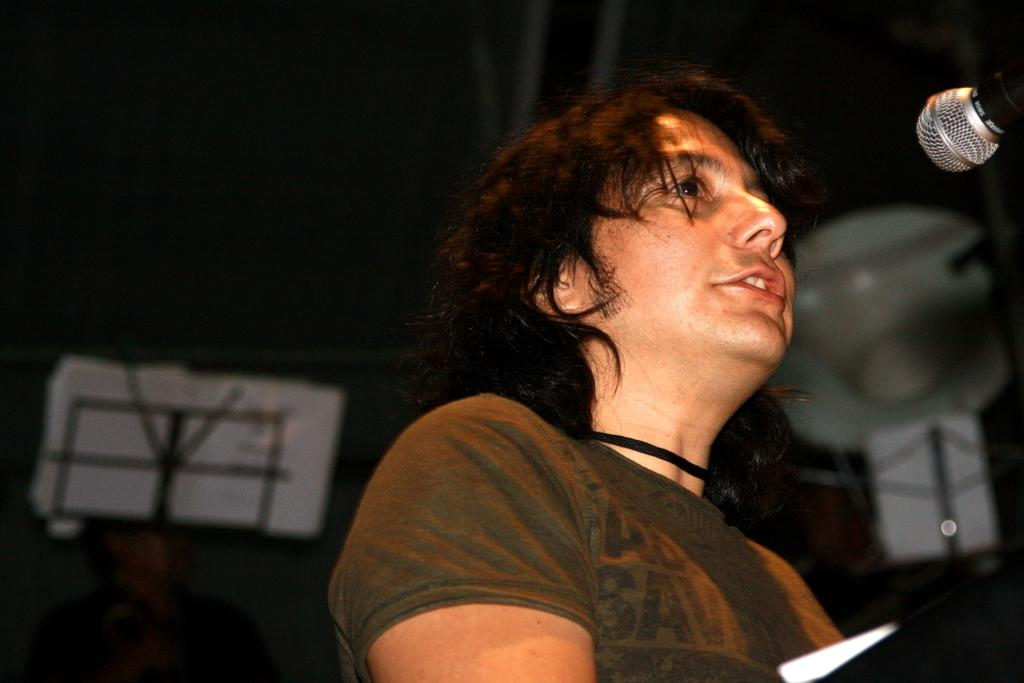What is the main subject of the image? The main subject of the image is a man. What is the man doing in the image? The man is standing and singing in the image. What is the man using while singing? The man is using a microphone in the image. What else can be seen in the image besides the man? There is a book on a stand in the image. What is the color of the background in the image? The background of the image is black. How many dolls are sitting on the man's shoulder in the image? There are no dolls present in the image. What type of locket is the man wearing around his neck in the image? The man is not wearing a locket in the image. 